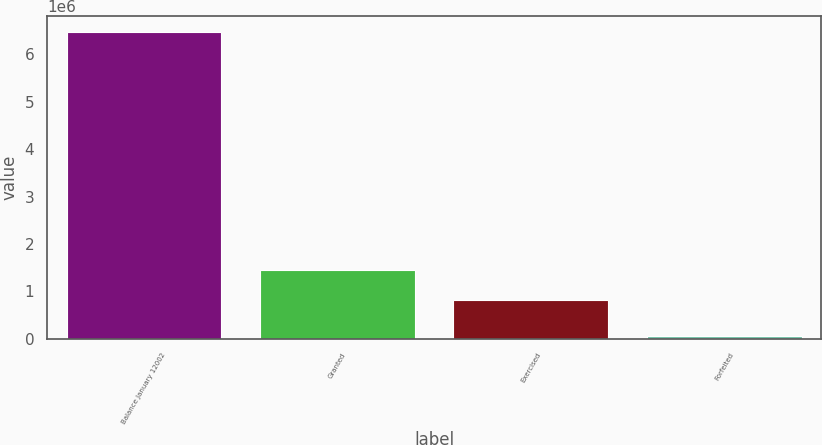Convert chart. <chart><loc_0><loc_0><loc_500><loc_500><bar_chart><fcel>Balance January 12002<fcel>Granted<fcel>Exercised<fcel>Forfeited<nl><fcel>6.47844e+06<fcel>1.45328e+06<fcel>811791<fcel>63550<nl></chart> 